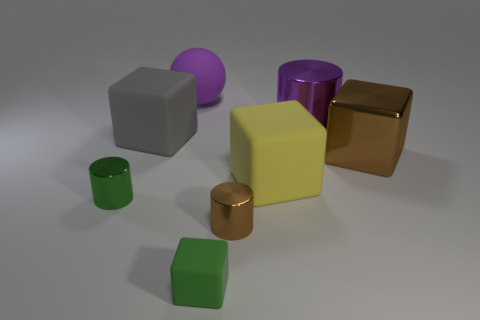Add 2 blocks. How many objects exist? 10 Subtract all cylinders. How many objects are left? 5 Add 4 small matte cylinders. How many small matte cylinders exist? 4 Subtract 0 cyan spheres. How many objects are left? 8 Subtract all big purple metallic cylinders. Subtract all big brown metal objects. How many objects are left? 6 Add 5 tiny green things. How many tiny green things are left? 7 